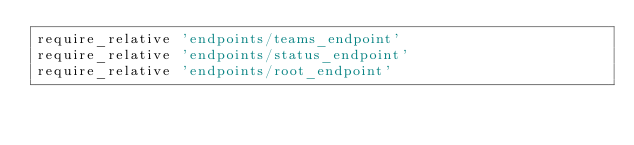Convert code to text. <code><loc_0><loc_0><loc_500><loc_500><_Ruby_>require_relative 'endpoints/teams_endpoint'
require_relative 'endpoints/status_endpoint'
require_relative 'endpoints/root_endpoint'
</code> 